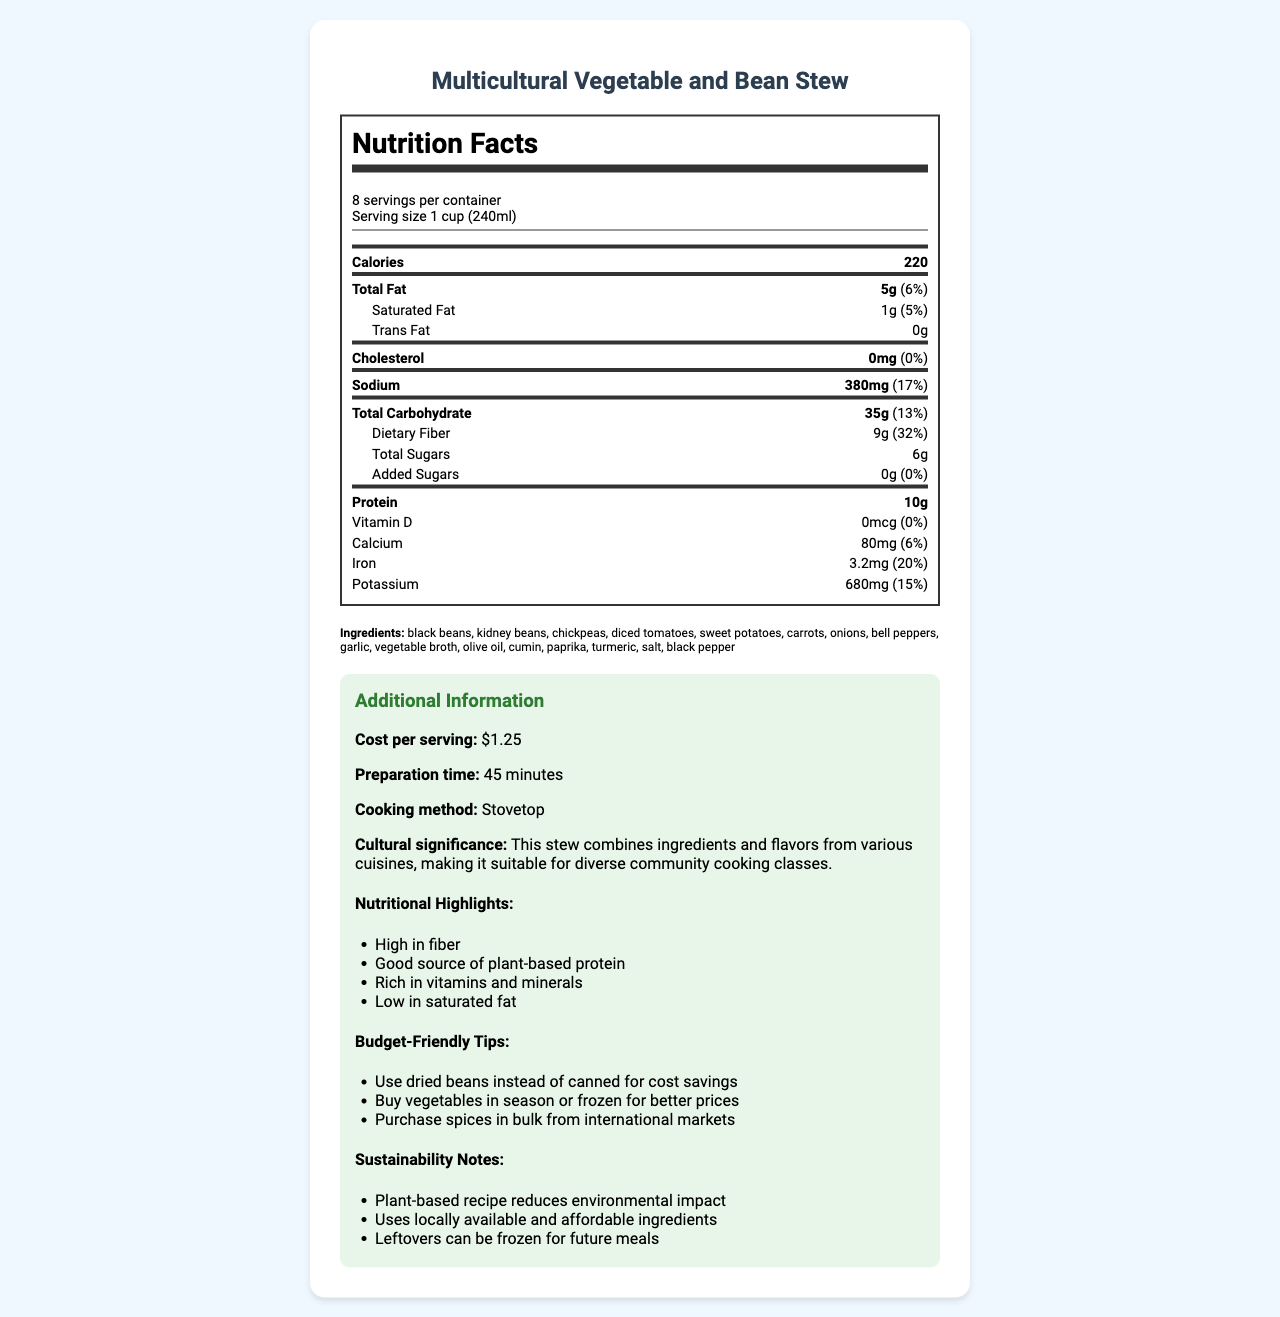What is the total fat content per serving? The total fat content is listed under the "Total Fat" section, which states 5g per serving.
Answer: 5g How many servings are in one container? The document states there are 8 servings per container.
Answer: 8 servings What percentage of the daily value for iron does each serving provide? It’s indicated that each serving provides 20% of the daily value for iron.
Answer: 20% List three ingredients in the Multicultural Vegetable and Bean Stew. These ingredients are prominently listed in the document.
Answer: Black beans, kidney beans, chickpeas What is the serving size for this recipe? The serving size mentioned in the document is 1 cup (240ml).
Answer: 1 cup (240ml) How much sodium does each serving contain? The sodium content per serving is provided as 380mg.
Answer: 380mg Is this recipe high in fiber? The nutritional highlights state that the recipe is high in fiber, which is corroborated by the dietary fiber content of 9g per serving (32% of the daily value).
Answer: Yes What is the cultural significance of the Multicultural Vegetable and Bean Stew? This information is mentioned under the "Cultural Significance" section.
Answer: The stew combines ingredients and flavors from various cuisines, making it suitable for diverse community cooking classes. How much does each serving of the stew cost? The document mentions that the cost per serving is $1.25.
Answer: $1.25 Does this recipe contain any allergens? The document explicitly states that there are no allergens in this recipe.
Answer: No How much protein is in each serving? The protein content per serving is listed as 10g.
Answer: 10g What is the preparation time for this recipe? The document notes that the preparation time is 45 minutes.
Answer: 45 minutes Which of the following strategies can help with budgeting when making this recipe? A. Use dried beans instead of canned B. Buy vegetables out of season C. Purchase spices in small quantities The document suggests using dried beans instead of canned for cost savings.
Answer: A How can leftovers from this recipe be managed to ensure sustainability? A. Throw them away B. Freeze them for future meals C. Leave them out at room temperature The document notes that leftovers can be frozen for future meals as part of sustainability practices.
Answer: B Is it suitable for someone trying to lower their cholesterol intake? The recipe contains 0mg of cholesterol per serving, making it suitable for someone aiming to lower their cholesterol intake.
Answer: Yes Summarize the nutritional benefits of this recipe. The nutritional highlights indicate that the stew offers these health benefits.
Answer: The Multicultural Vegetable and Bean Stew is high in fiber, a good source of plant-based protein, rich in vitamins and minerals, and low in saturated fat. What is the primary cooking method for this recipe? The document states that the primary cooking method for the recipe is stovetop.
Answer: Stovetop What type of oil is used in this recipe? Olive oil is listed among the ingredients.
Answer: Olive oil How much saturated fat does each serving contain? The saturated fat content per serving is provided as 1g.
Answer: 1g Can you find the exact amount of cumin used in the recipe? The document provides a list of ingredients but does not specify the exact amounts.
Answer: Not enough information What vitamin D percentage of the daily value does each serving provide? The vitamin D content per serving is 0mcg, equating to 0% of the daily value.
Answer: 0% How does this recipe support environmental sustainability? These sustainability benefits are highlighted in the document.
Answer: The plant-based recipe reduces environmental impact, it uses locally available and affordable ingredients, and leftovers can be frozen for future meals. 